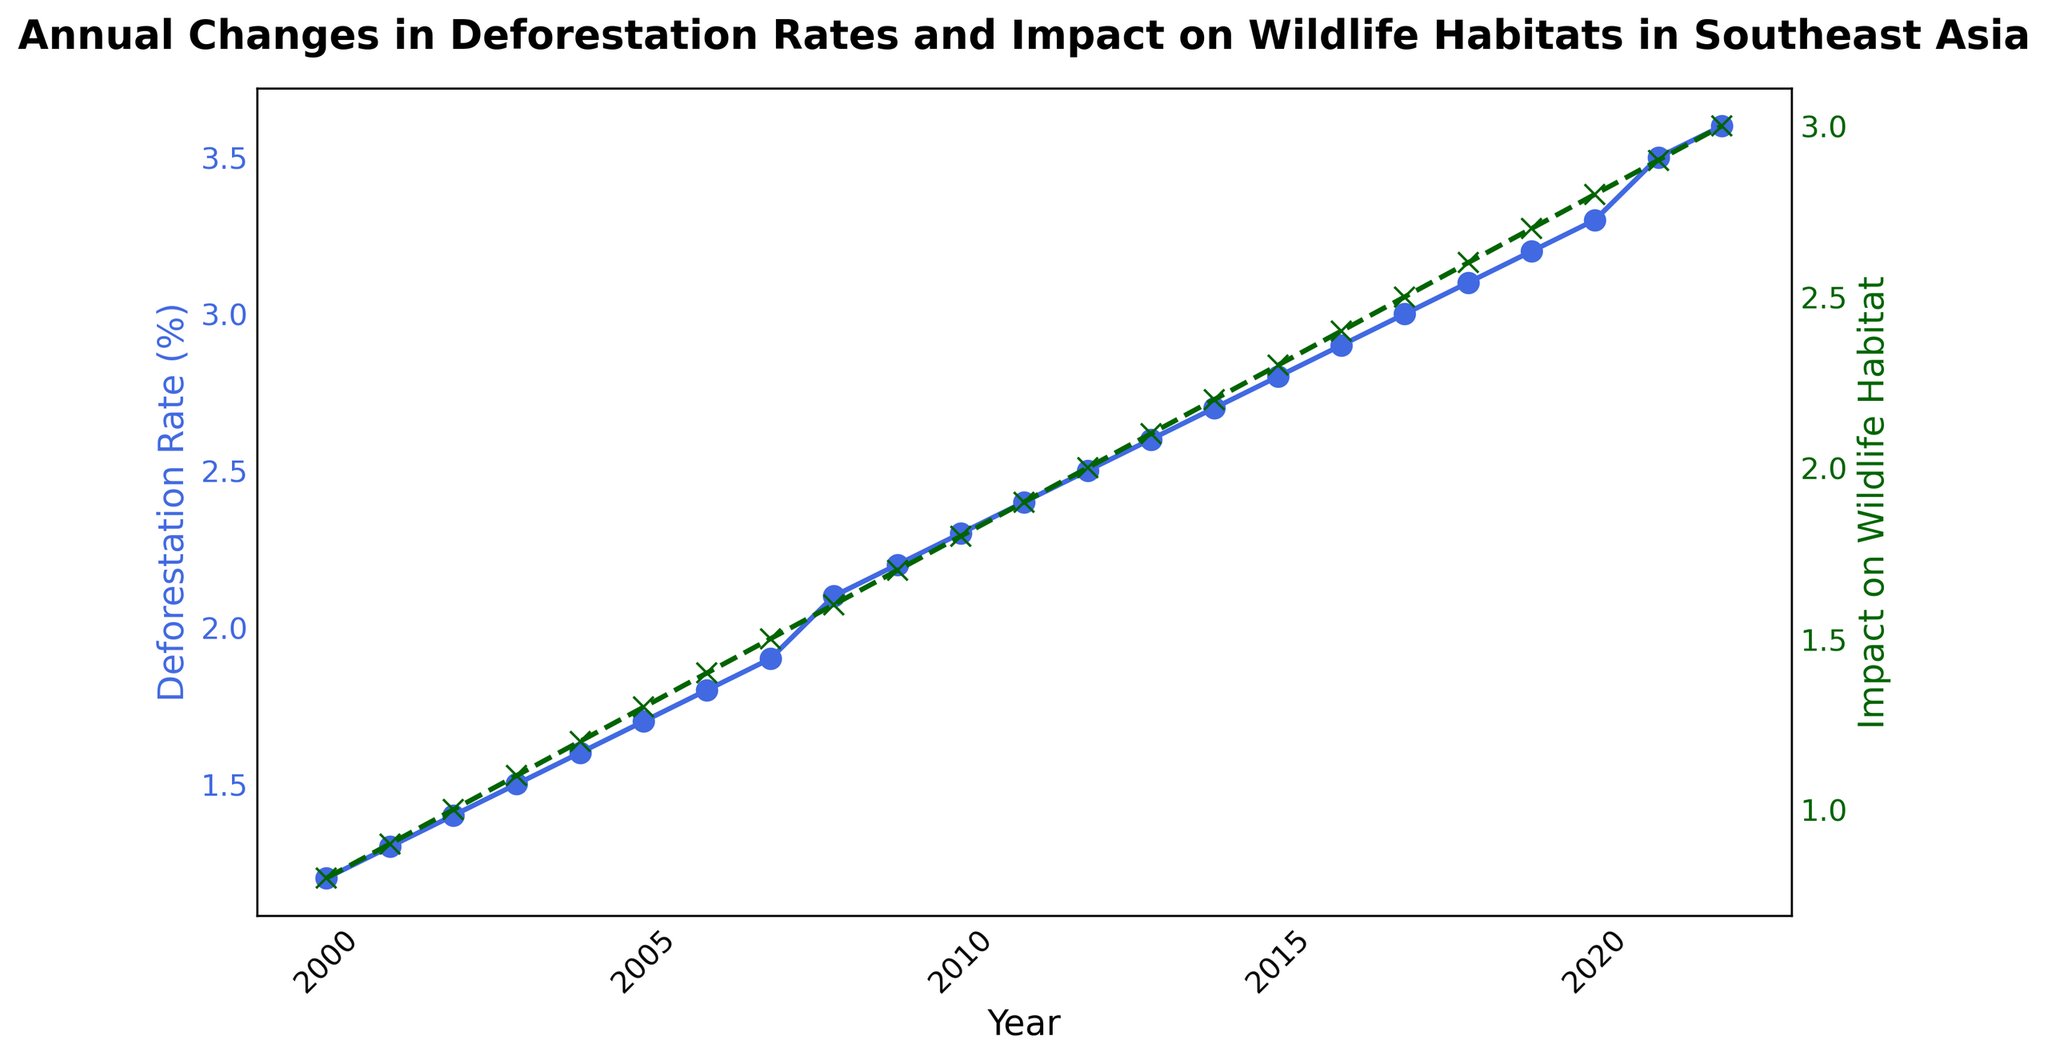What is the average deforestation rate from 2000 to 2010? To find the average deforestation rate, sum the deforestation rates from 2000 to 2010 and divide by the number of years (11). The sum is 1.2 + 1.3 + 1.4 + 1.5 + 1.6 + 1.7 + 1.8 + 1.9 + 2.1 + 2.2 + 2.3 = 19.0, so the average is 19.0 / 11.
Answer: 1.73 How much did the deforestation rate increase from the year 2000 to 2022? Subtract the deforestation rate in 2000 from the deforestation rate in 2022. The difference is 3.6 - 1.2 = 2.4.
Answer: 2.4 In which year did the impact on wildlife habitat reach 2.0? Look at the data for the impact on wildlife habitat and find the year when it reaches 2.0. It reached 2.0 in 2012.
Answer: 2012 Which year saw the highest yearly increase in deforestation rate? To find the highest yearly increase, calculate the difference in deforestation rate for each consecutive year and identify the largest difference. The highest increase of 0.2 occurred between 2020 and 2021.
Answer: 2021 How does the trend in deforestation rates compare to the trend in the impact on wildlife habitats? Compare the slopes and patterns of the lines representing deforestation rates and impact on wildlife habitats. Both lines show a consistent upward trend, although the deforestation rate generally increases slightly faster than the impact on wildlife habitat.
Answer: Both increasing What is the difference in the impact on wildlife habitats between 2000 and 2022? Subtract the impact on wildlife habitats in 2000 from the impact in 2022. The difference is 3.0 - 0.8 = 2.2.
Answer: 2.2 By how much did the deforestation rate change between 2010 and 2022? Subtract the deforestation rate in 2010 from the rate in 2022. The difference is 3.6 - 2.3 = 1.3.
Answer: 1.3 During which period did the deforestation rate and the impact on wildlife habitats have a similar rate of increase? Analyze the plot and identify the period when both lines have comparable slopes. Such a period appears roughly between 2019 and 2021, both lines steeply increase during this period.
Answer: 2019-2021 What is the median impact on wildlife habitat from 2000 to 2022? List out all the impacts on wildlife habitats from 2000 to 2022, and find the middle value. The values are 0.8, 0.9, 1.0, 1.1, 1.2, 1.3, 1.4, 1.5, 1.6, 1.7, 1.8, 1.9, 2.0, 2.1, 2.2, 2.3, 2.4, 2.5, 2.6, 2.7, 2.8, 2.9, 3.0, so the median is 1.9.
Answer: 1.9 